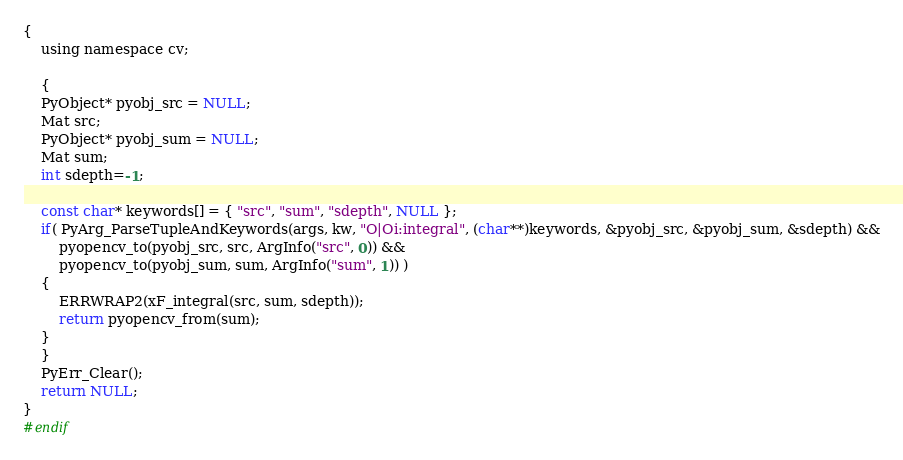<code> <loc_0><loc_0><loc_500><loc_500><_C_>{
    using namespace cv;

    {
    PyObject* pyobj_src = NULL;
    Mat src;
    PyObject* pyobj_sum = NULL;
    Mat sum;
    int sdepth=-1;

    const char* keywords[] = { "src", "sum", "sdepth", NULL };
    if( PyArg_ParseTupleAndKeywords(args, kw, "O|Oi:integral", (char**)keywords, &pyobj_src, &pyobj_sum, &sdepth) &&
        pyopencv_to(pyobj_src, src, ArgInfo("src", 0)) &&
        pyopencv_to(pyobj_sum, sum, ArgInfo("sum", 1)) )
    {
        ERRWRAP2(xF_integral(src, sum, sdepth));
        return pyopencv_from(sum);
    }
    }
    PyErr_Clear(); 
    return NULL;
}
#endif
</code> 